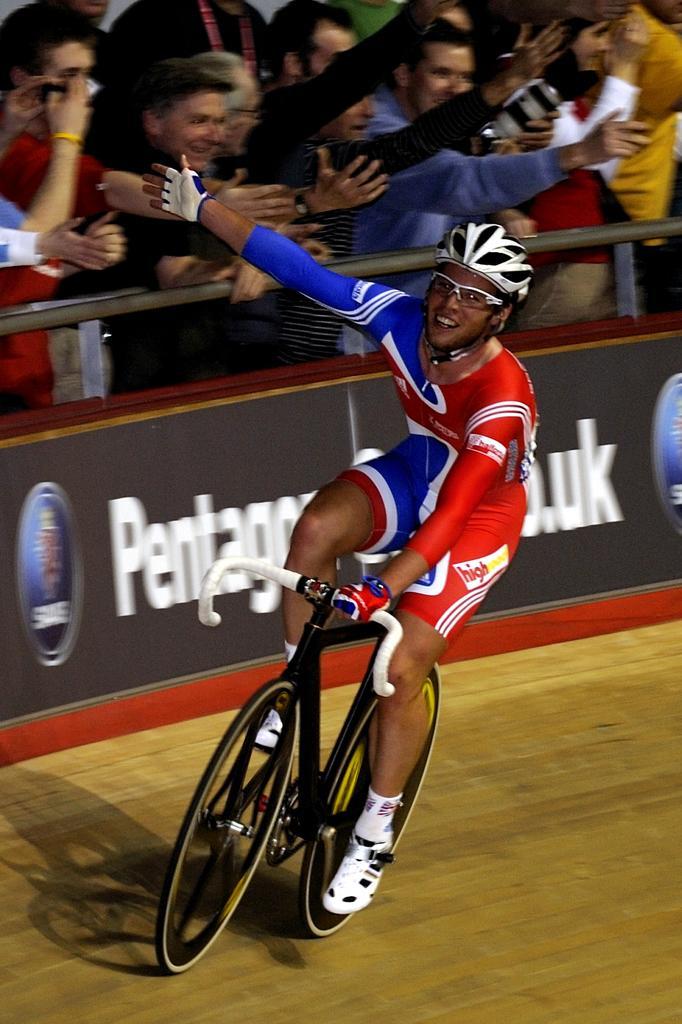Describe this image in one or two sentences. The man in red and blue dress is riding bicycle. He is wearing white helmet on his head. Beside him, we see a board on which some text is written on it and behind that, we see many people encouraging the man who is riding bicycle. 